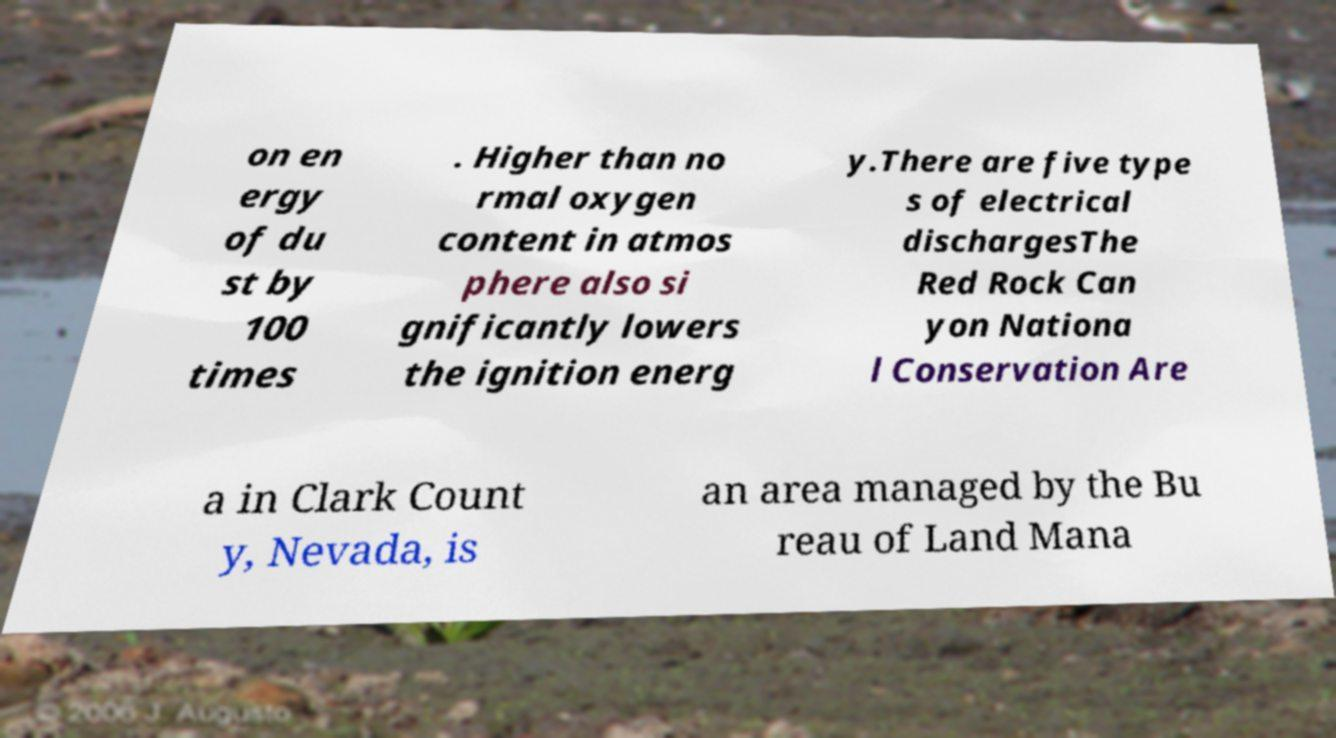What messages or text are displayed in this image? I need them in a readable, typed format. on en ergy of du st by 100 times . Higher than no rmal oxygen content in atmos phere also si gnificantly lowers the ignition energ y.There are five type s of electrical dischargesThe Red Rock Can yon Nationa l Conservation Are a in Clark Count y, Nevada, is an area managed by the Bu reau of Land Mana 